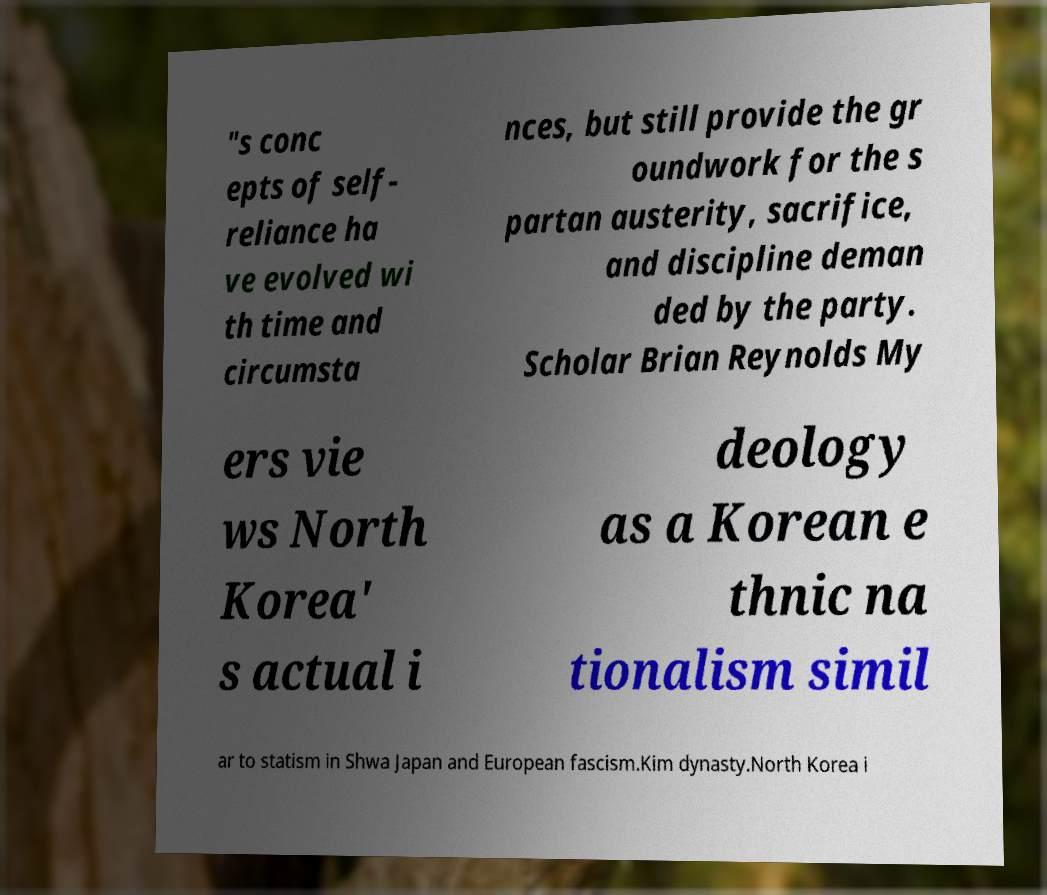Please read and relay the text visible in this image. What does it say? "s conc epts of self- reliance ha ve evolved wi th time and circumsta nces, but still provide the gr oundwork for the s partan austerity, sacrifice, and discipline deman ded by the party. Scholar Brian Reynolds My ers vie ws North Korea' s actual i deology as a Korean e thnic na tionalism simil ar to statism in Shwa Japan and European fascism.Kim dynasty.North Korea i 